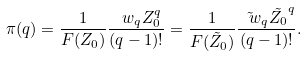<formula> <loc_0><loc_0><loc_500><loc_500>\pi ( q ) = \frac { 1 } { F ( Z _ { 0 } ) } \frac { \ w _ { q } Z _ { 0 } ^ { q } } { ( q - 1 ) ! } = \frac { 1 } { F ( \tilde { Z } _ { 0 } ) } \frac { \tilde { \ w } _ { q } \tilde { Z _ { 0 } } ^ { q } } { ( q - 1 ) ! } .</formula> 